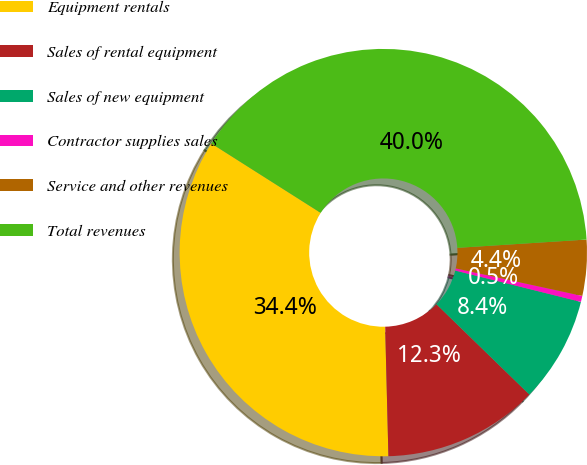Convert chart. <chart><loc_0><loc_0><loc_500><loc_500><pie_chart><fcel>Equipment rentals<fcel>Sales of rental equipment<fcel>Sales of new equipment<fcel>Contractor supplies sales<fcel>Service and other revenues<fcel>Total revenues<nl><fcel>34.4%<fcel>12.33%<fcel>8.38%<fcel>0.48%<fcel>4.43%<fcel>39.98%<nl></chart> 